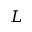<formula> <loc_0><loc_0><loc_500><loc_500>L</formula> 